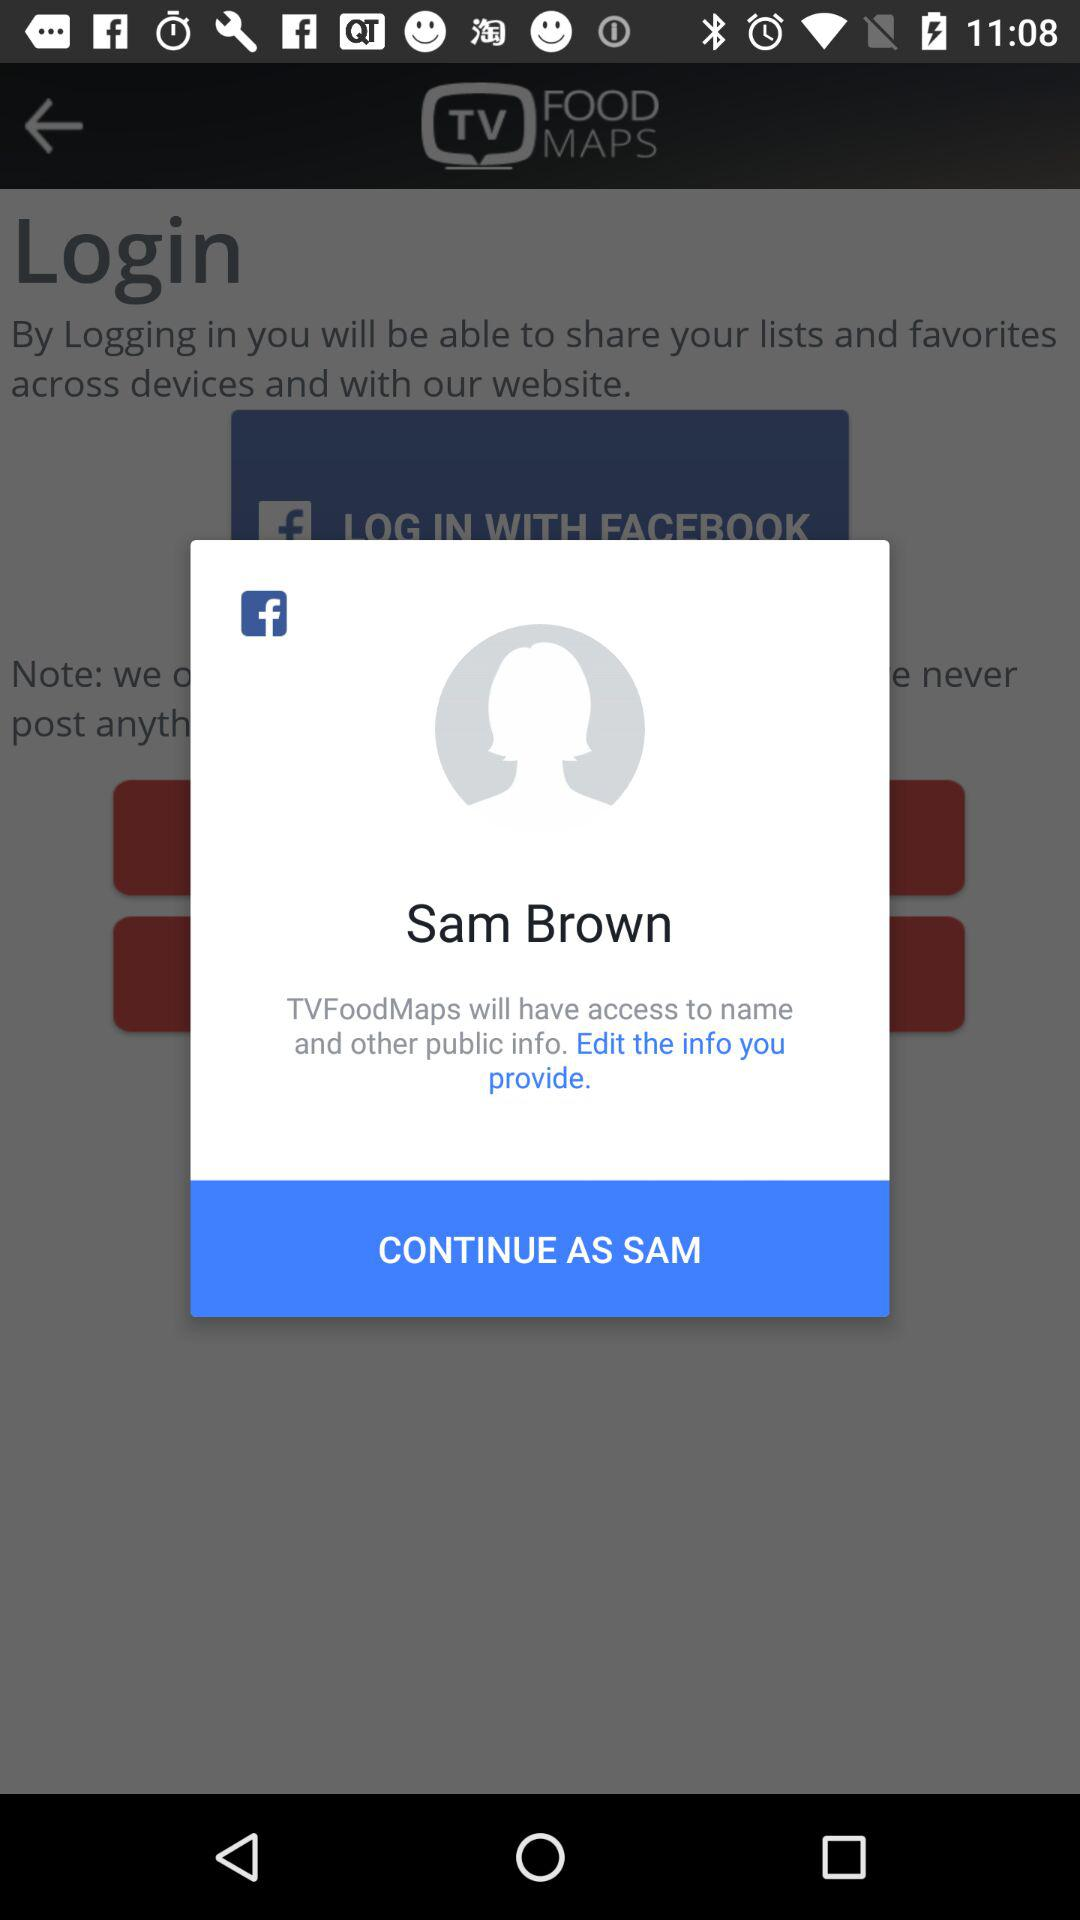How much does Sam Brown weigh?
When the provided information is insufficient, respond with <no answer>. <no answer> 